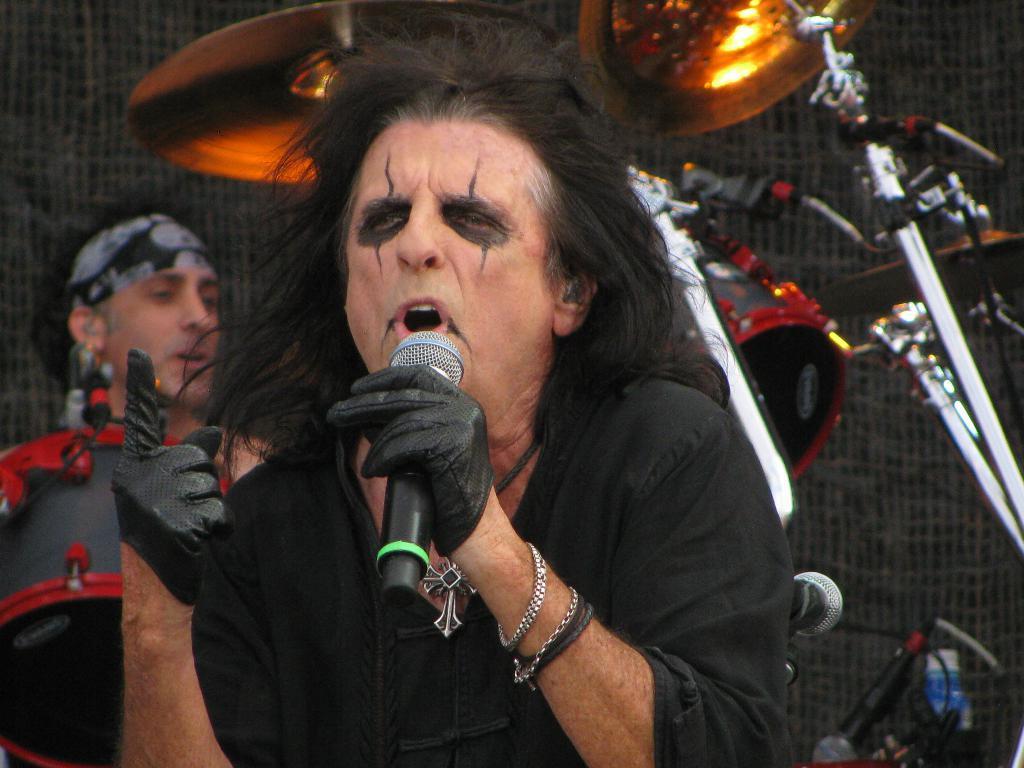Describe this image in one or two sentences. This picture seems to be of inside. In the center there is a man wearing black color t-shirt, holding microphone and singing, behind him there is a man seems to be standing and there is a drum in front of him and in the background there is a musical instrument attached to the stand. 